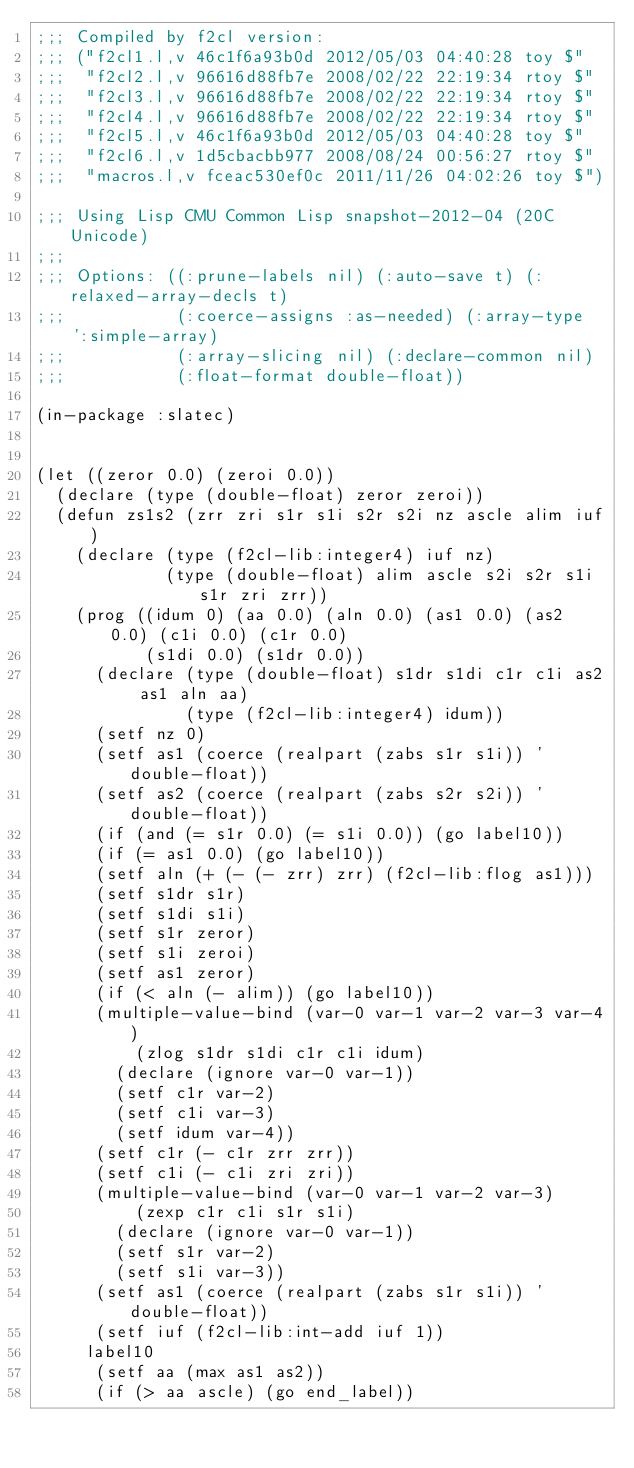<code> <loc_0><loc_0><loc_500><loc_500><_Lisp_>;;; Compiled by f2cl version:
;;; ("f2cl1.l,v 46c1f6a93b0d 2012/05/03 04:40:28 toy $"
;;;  "f2cl2.l,v 96616d88fb7e 2008/02/22 22:19:34 rtoy $"
;;;  "f2cl3.l,v 96616d88fb7e 2008/02/22 22:19:34 rtoy $"
;;;  "f2cl4.l,v 96616d88fb7e 2008/02/22 22:19:34 rtoy $"
;;;  "f2cl5.l,v 46c1f6a93b0d 2012/05/03 04:40:28 toy $"
;;;  "f2cl6.l,v 1d5cbacbb977 2008/08/24 00:56:27 rtoy $"
;;;  "macros.l,v fceac530ef0c 2011/11/26 04:02:26 toy $")

;;; Using Lisp CMU Common Lisp snapshot-2012-04 (20C Unicode)
;;; 
;;; Options: ((:prune-labels nil) (:auto-save t) (:relaxed-array-decls t)
;;;           (:coerce-assigns :as-needed) (:array-type ':simple-array)
;;;           (:array-slicing nil) (:declare-common nil)
;;;           (:float-format double-float))

(in-package :slatec)


(let ((zeror 0.0) (zeroi 0.0))
  (declare (type (double-float) zeror zeroi))
  (defun zs1s2 (zrr zri s1r s1i s2r s2i nz ascle alim iuf)
    (declare (type (f2cl-lib:integer4) iuf nz)
             (type (double-float) alim ascle s2i s2r s1i s1r zri zrr))
    (prog ((idum 0) (aa 0.0) (aln 0.0) (as1 0.0) (as2 0.0) (c1i 0.0) (c1r 0.0)
           (s1di 0.0) (s1dr 0.0))
      (declare (type (double-float) s1dr s1di c1r c1i as2 as1 aln aa)
               (type (f2cl-lib:integer4) idum))
      (setf nz 0)
      (setf as1 (coerce (realpart (zabs s1r s1i)) 'double-float))
      (setf as2 (coerce (realpart (zabs s2r s2i)) 'double-float))
      (if (and (= s1r 0.0) (= s1i 0.0)) (go label10))
      (if (= as1 0.0) (go label10))
      (setf aln (+ (- (- zrr) zrr) (f2cl-lib:flog as1)))
      (setf s1dr s1r)
      (setf s1di s1i)
      (setf s1r zeror)
      (setf s1i zeroi)
      (setf as1 zeror)
      (if (< aln (- alim)) (go label10))
      (multiple-value-bind (var-0 var-1 var-2 var-3 var-4)
          (zlog s1dr s1di c1r c1i idum)
        (declare (ignore var-0 var-1))
        (setf c1r var-2)
        (setf c1i var-3)
        (setf idum var-4))
      (setf c1r (- c1r zrr zrr))
      (setf c1i (- c1i zri zri))
      (multiple-value-bind (var-0 var-1 var-2 var-3)
          (zexp c1r c1i s1r s1i)
        (declare (ignore var-0 var-1))
        (setf s1r var-2)
        (setf s1i var-3))
      (setf as1 (coerce (realpart (zabs s1r s1i)) 'double-float))
      (setf iuf (f2cl-lib:int-add iuf 1))
     label10
      (setf aa (max as1 as2))
      (if (> aa ascle) (go end_label))</code> 